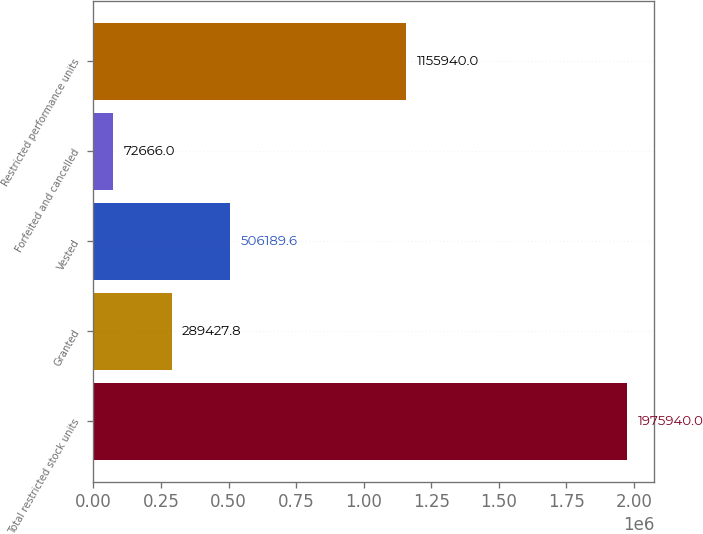Convert chart to OTSL. <chart><loc_0><loc_0><loc_500><loc_500><bar_chart><fcel>Total restricted stock units<fcel>Granted<fcel>Vested<fcel>Forfeited and cancelled<fcel>Restricted performance units<nl><fcel>1.97594e+06<fcel>289428<fcel>506190<fcel>72666<fcel>1.15594e+06<nl></chart> 